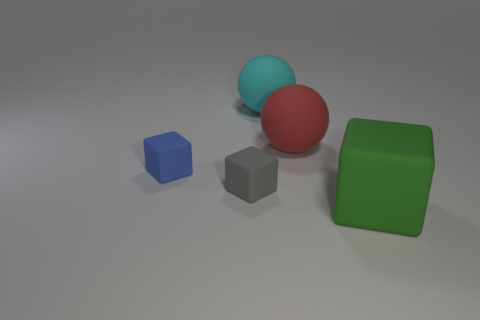Add 1 big green things. How many objects exist? 6 Subtract all cubes. How many objects are left? 2 Add 3 tiny brown metallic blocks. How many tiny brown metallic blocks exist? 3 Subtract 0 gray spheres. How many objects are left? 5 Subtract all big red metallic spheres. Subtract all blue matte objects. How many objects are left? 4 Add 5 big red things. How many big red things are left? 6 